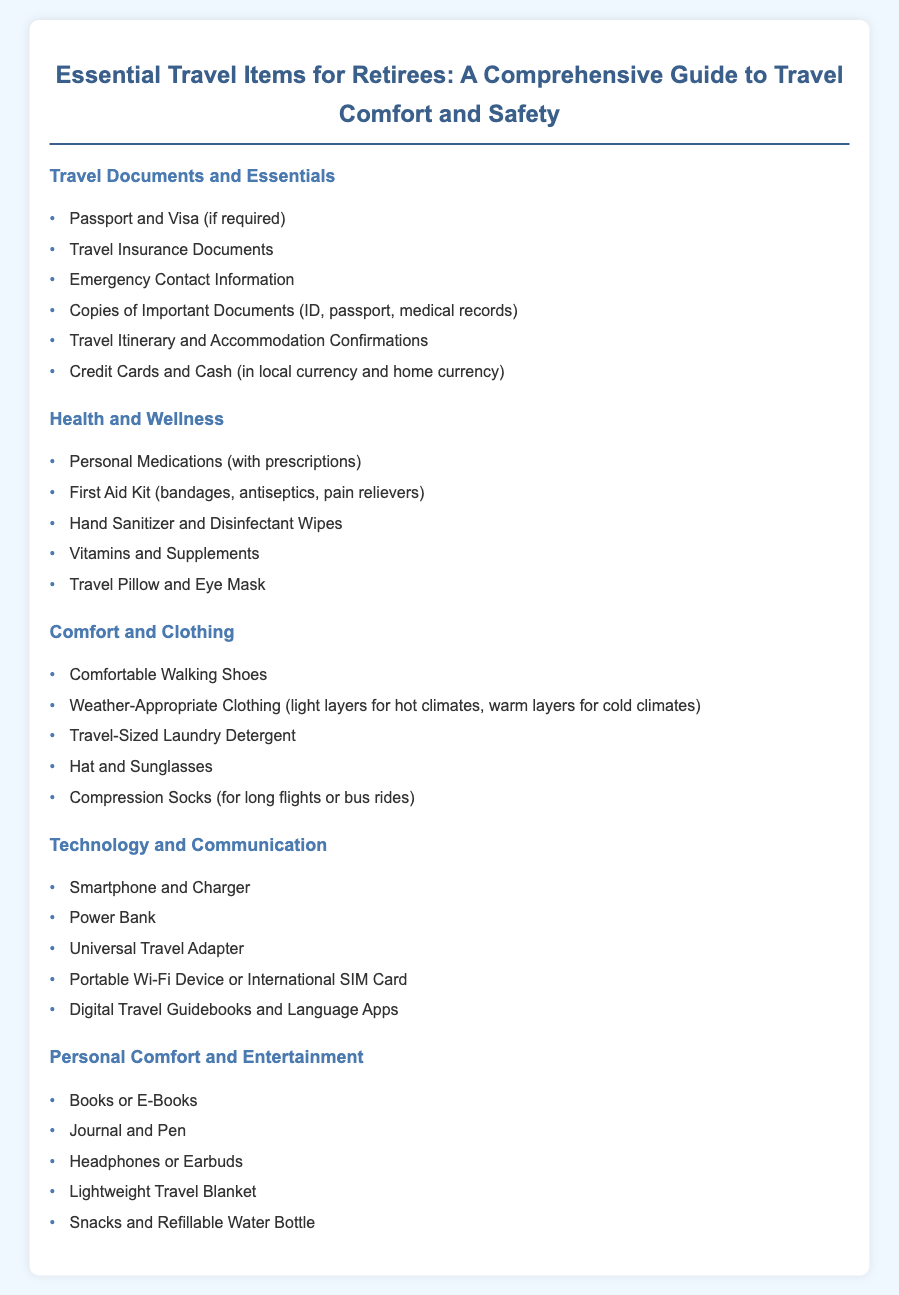what is the first item listed under Travel Documents and Essentials? The first item listed is "Passport and Visa (if required)".
Answer: Passport and Visa (if required) how many items are listed under Health and Wellness? There are five items listed under Health and Wellness.
Answer: 5 what is included in the Comfort and Clothing category? The category includes comfortable walking shoes, weather-appropriate clothing, travel-sized laundry detergent, hat and sunglasses, and compression socks.
Answer: Comfortable Walking Shoes, Weather-Appropriate Clothing, Travel-Sized Laundry Detergent, Hat and Sunglasses, Compression Socks which personal item is recommended for long flights? "Compression Socks (for long flights or bus rides)" is recommended for long flights.
Answer: Compression Socks what device is suggested for charging on the go? The document suggests a "Power Bank" for charging on the go.
Answer: Power Bank how many categories of essential travel items are listed in the document? There are five categories of essential travel items listed in the document.
Answer: 5 what general category includes "snacks and refillable water bottle"? "Personal Comfort and Entertainment" is the category that includes "snacks and refillable water bottle".
Answer: Personal Comfort and Entertainment what type of clothing should retirees bring for varying climates? "Weather-Appropriate Clothing" should be brought for varying climates.
Answer: Weather-Appropriate Clothing 